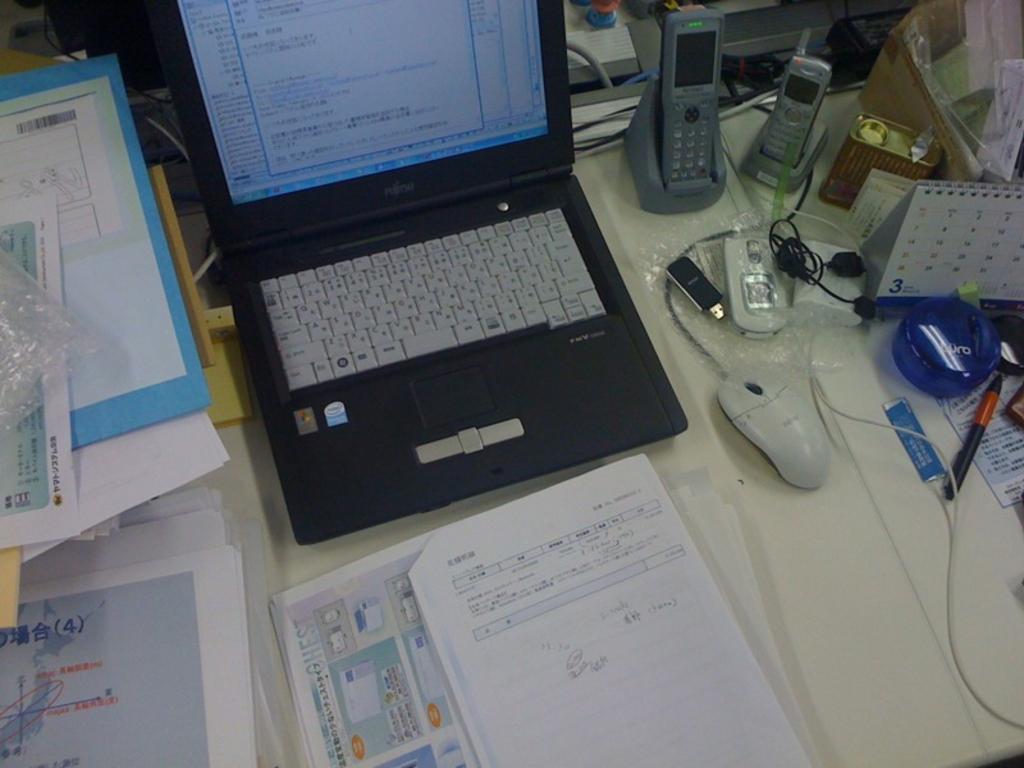<image>
Provide a brief description of the given image. A Fujitsu laptop that runs windows is open on a cluttered desk. 